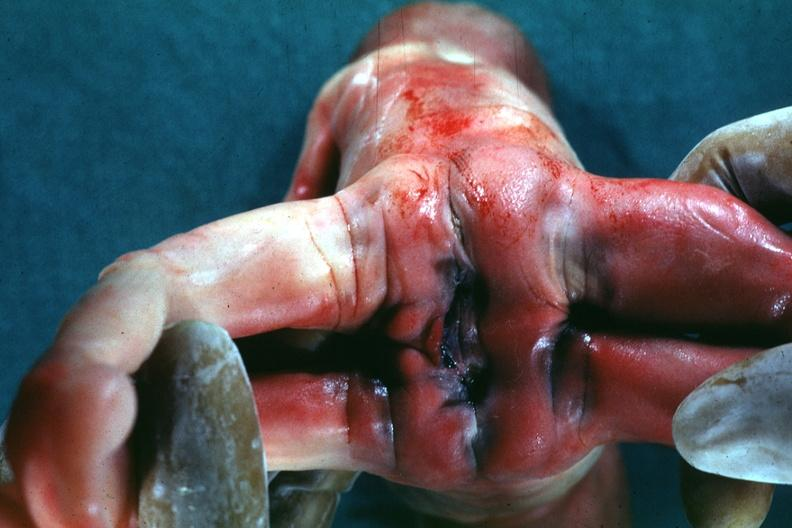does this image show joined anterior at chest and abdomen view from buttocks?
Answer the question using a single word or phrase. Yes 